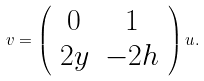Convert formula to latex. <formula><loc_0><loc_0><loc_500><loc_500>v = \left ( \begin{array} { c c } 0 & 1 \\ 2 y & - 2 h \\ \end{array} \right ) u .</formula> 